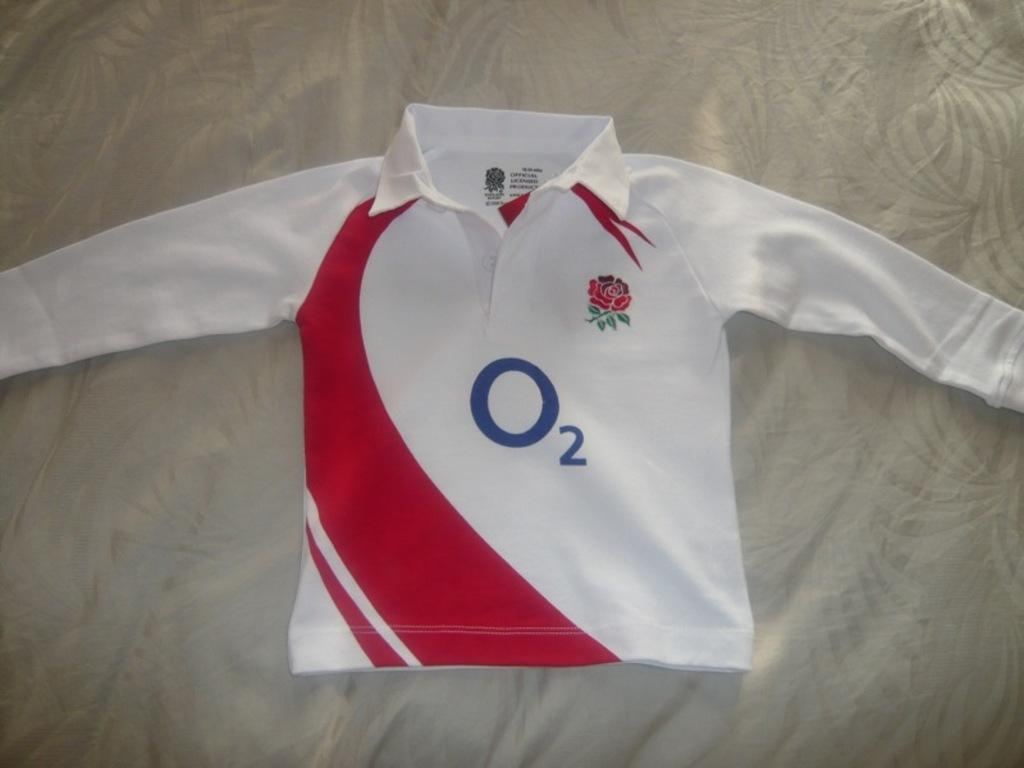<image>
Share a concise interpretation of the image provided. White jersey with red stripe that has a number 2 on it. 